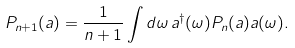<formula> <loc_0><loc_0><loc_500><loc_500>P _ { n + 1 } ( a ) = \frac { 1 } { n + 1 } \int d \omega \, a ^ { \dag } ( \omega ) P _ { n } ( a ) a ( \omega ) .</formula> 